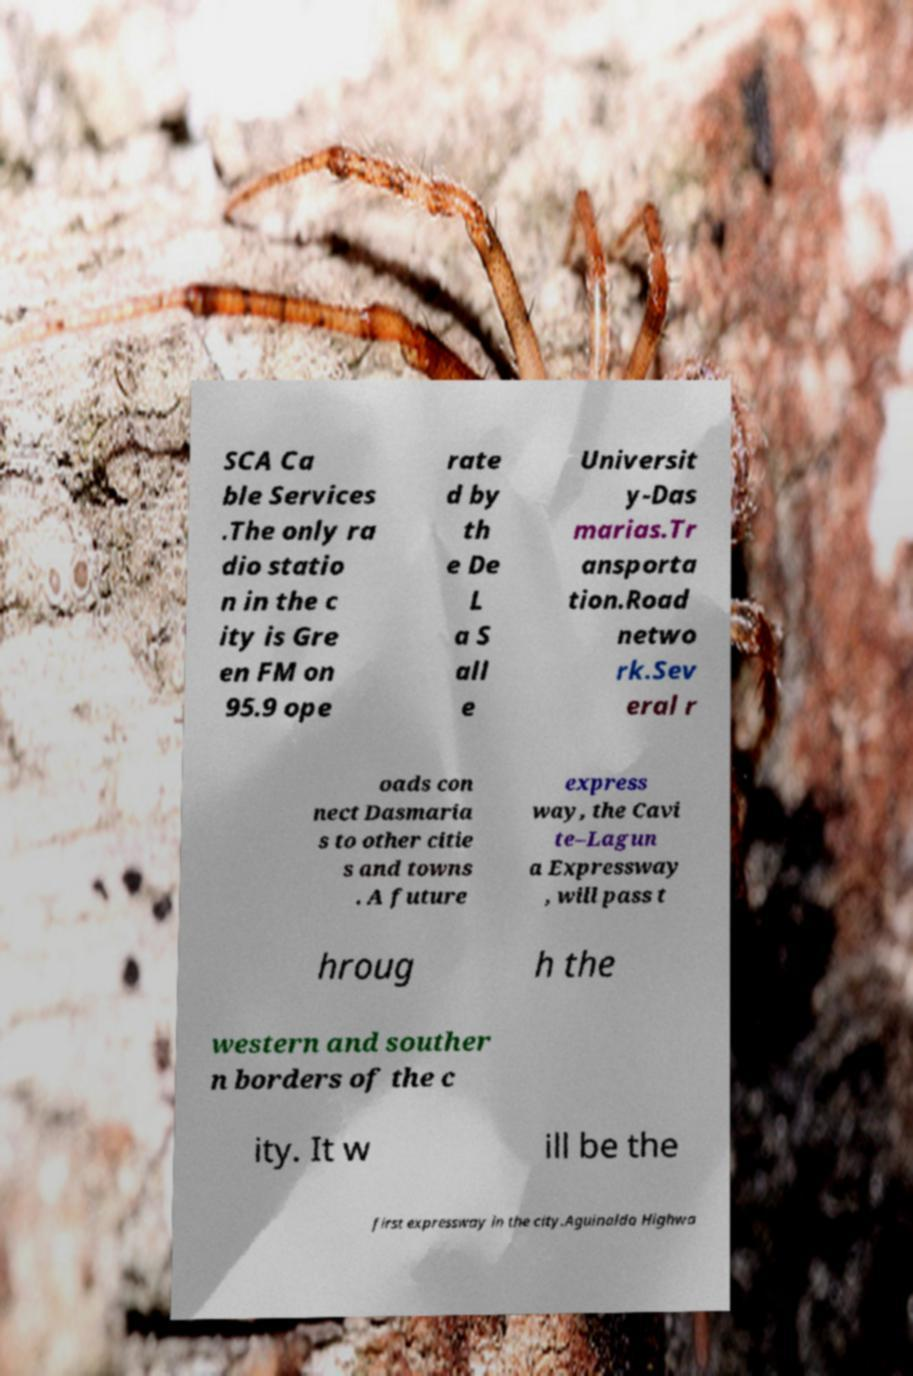Please read and relay the text visible in this image. What does it say? SCA Ca ble Services .The only ra dio statio n in the c ity is Gre en FM on 95.9 ope rate d by th e De L a S all e Universit y-Das marias.Tr ansporta tion.Road netwo rk.Sev eral r oads con nect Dasmaria s to other citie s and towns . A future express way, the Cavi te–Lagun a Expressway , will pass t hroug h the western and souther n borders of the c ity. It w ill be the first expressway in the city.Aguinaldo Highwa 